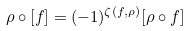Convert formula to latex. <formula><loc_0><loc_0><loc_500><loc_500>\rho \circ [ f ] = ( - 1 ) ^ { \zeta ( f , \rho ) } [ \rho \circ f ]</formula> 